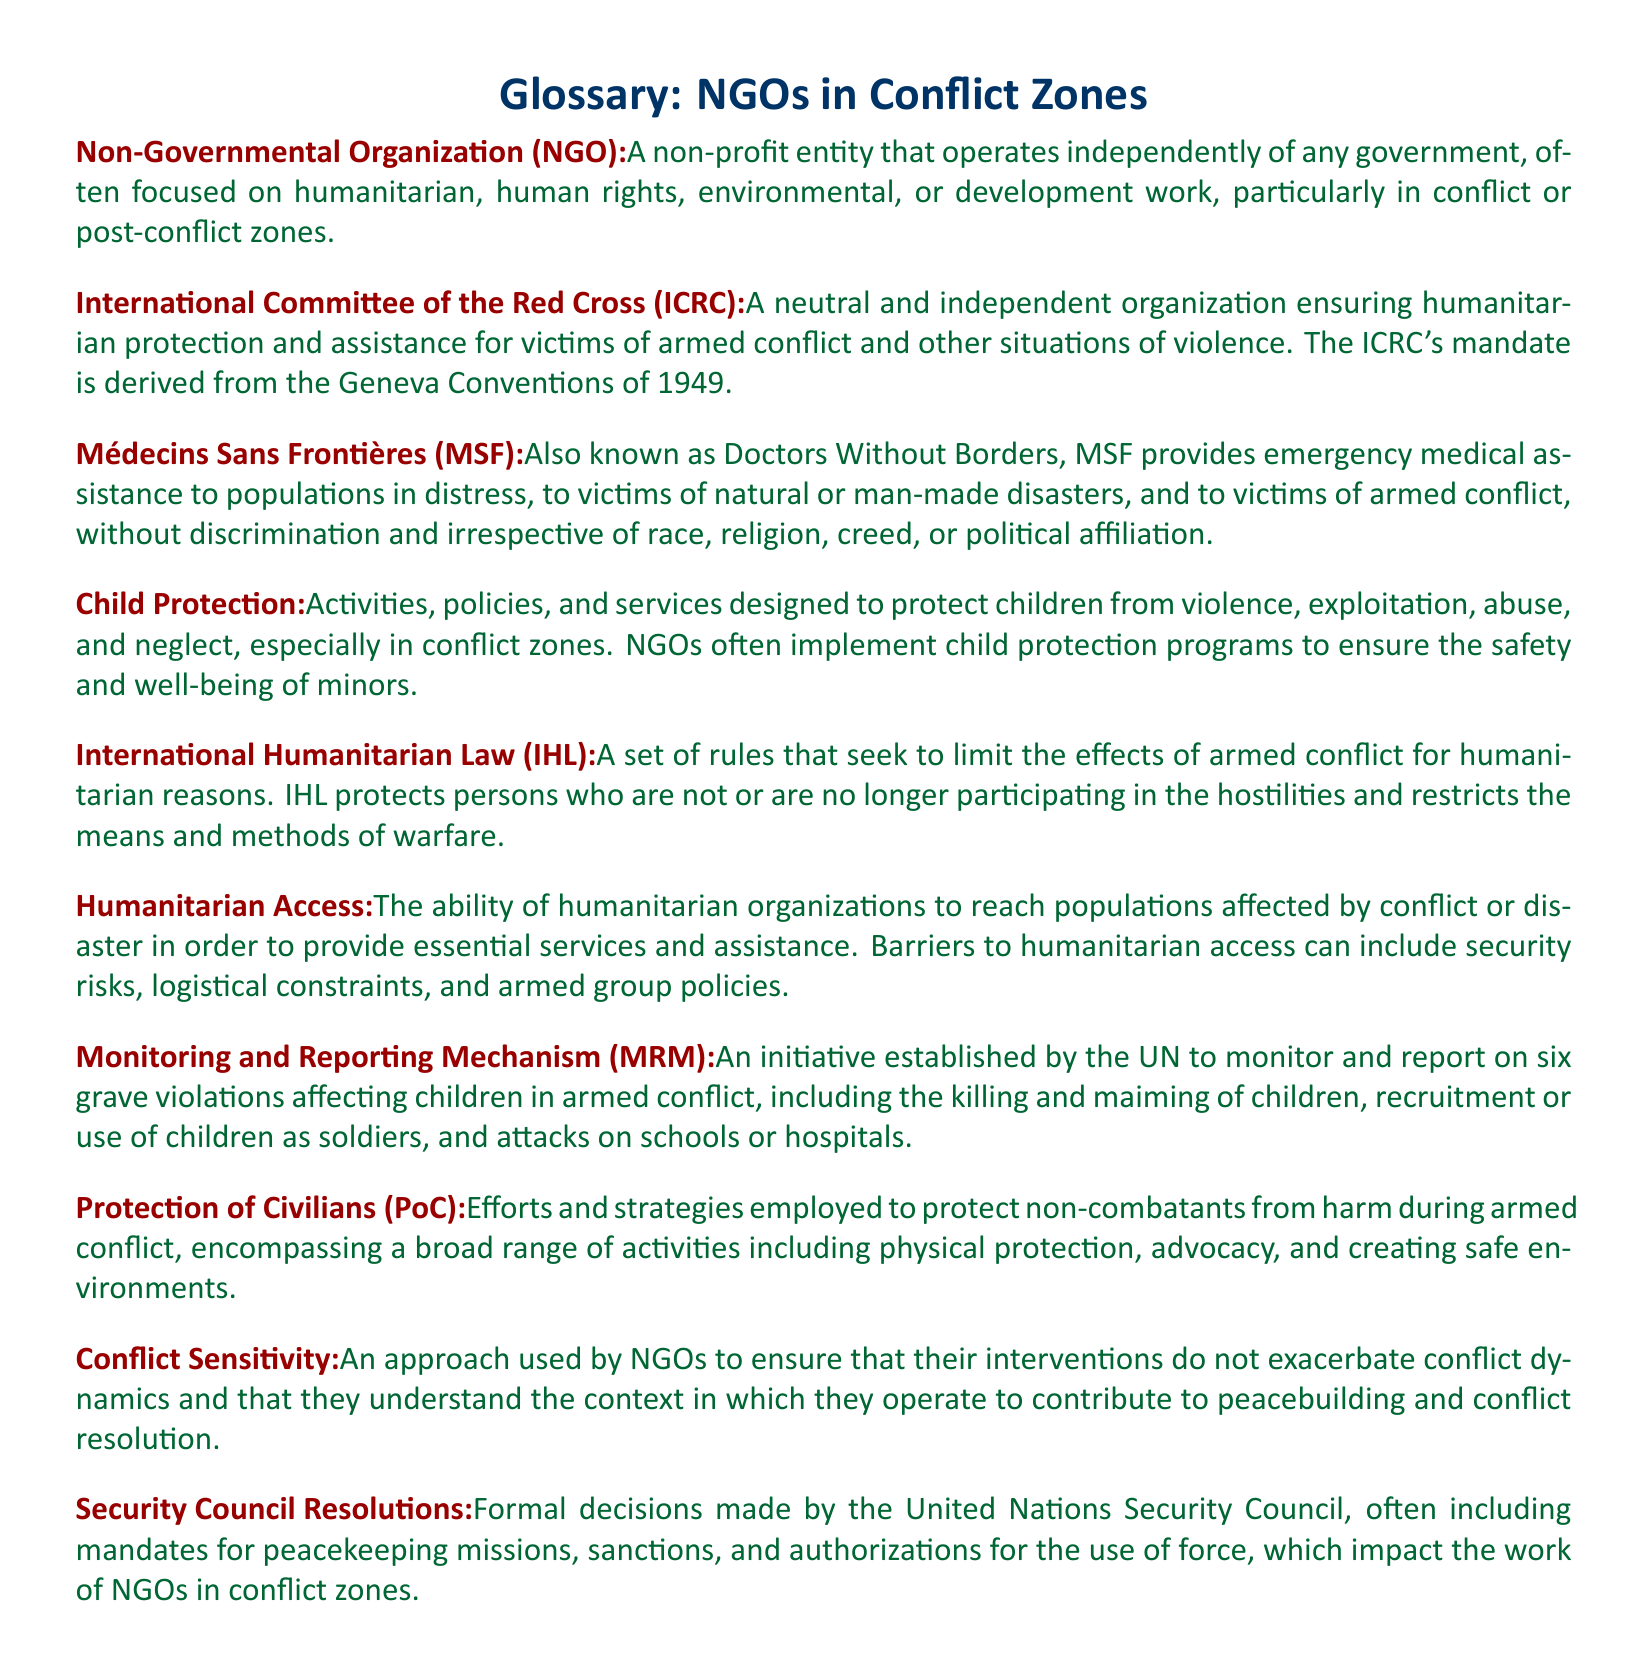What is the abbreviation for Médecins Sans Frontières? The term is referenced in the document as the abbreviated name for Doctors Without Borders.
Answer: MSF What does IHL stand for? The document defines the abbreviation IHL as International Humanitarian Law.
Answer: International Humanitarian Law What is the main focus of the International Committee of the Red Cross? This organization aims to ensure humanitarian protection and assistance for victims of armed conflict and other situations of violence.
Answer: Humanitarian protection and assistance What does the term "Protection of Civilians (PoC)" refer to? The document outlines that this term encompasses efforts and strategies to protect non-combatants in armed conflict.
Answer: Efforts and strategies to protect non-combatants What is the role of NGOs in child protection according to the document? The document states that NGOs implement programs to ensure the safety and well-being of minors in conflict zones.
Answer: Ensure safety and well-being of minors What is the purpose of the Monitoring and Reporting Mechanism (MRM)? The document details that this initiative is to monitor and report on grave violations affecting children in armed conflict.
Answer: Monitor and report grave violations What does "Conflict Sensitivity" entail in NGO operations? The document explains that it involves ensuring interventions do not exacerbate conflict dynamics and understanding the operational context.
Answer: Ensuring interventions do not exacerbate conflict How many grave violations are monitored by the MRM? The document specifies that there are six grave violations impacting children in armed conflict being monitored.
Answer: Six What is the function of Security Council Resolutions? According to the document, these resolutions include mandates for peacekeeping missions, sanctions, and authorizations impacting NGOs.
Answer: Mandates for peacekeeping missions, sanctions, and authorizations 